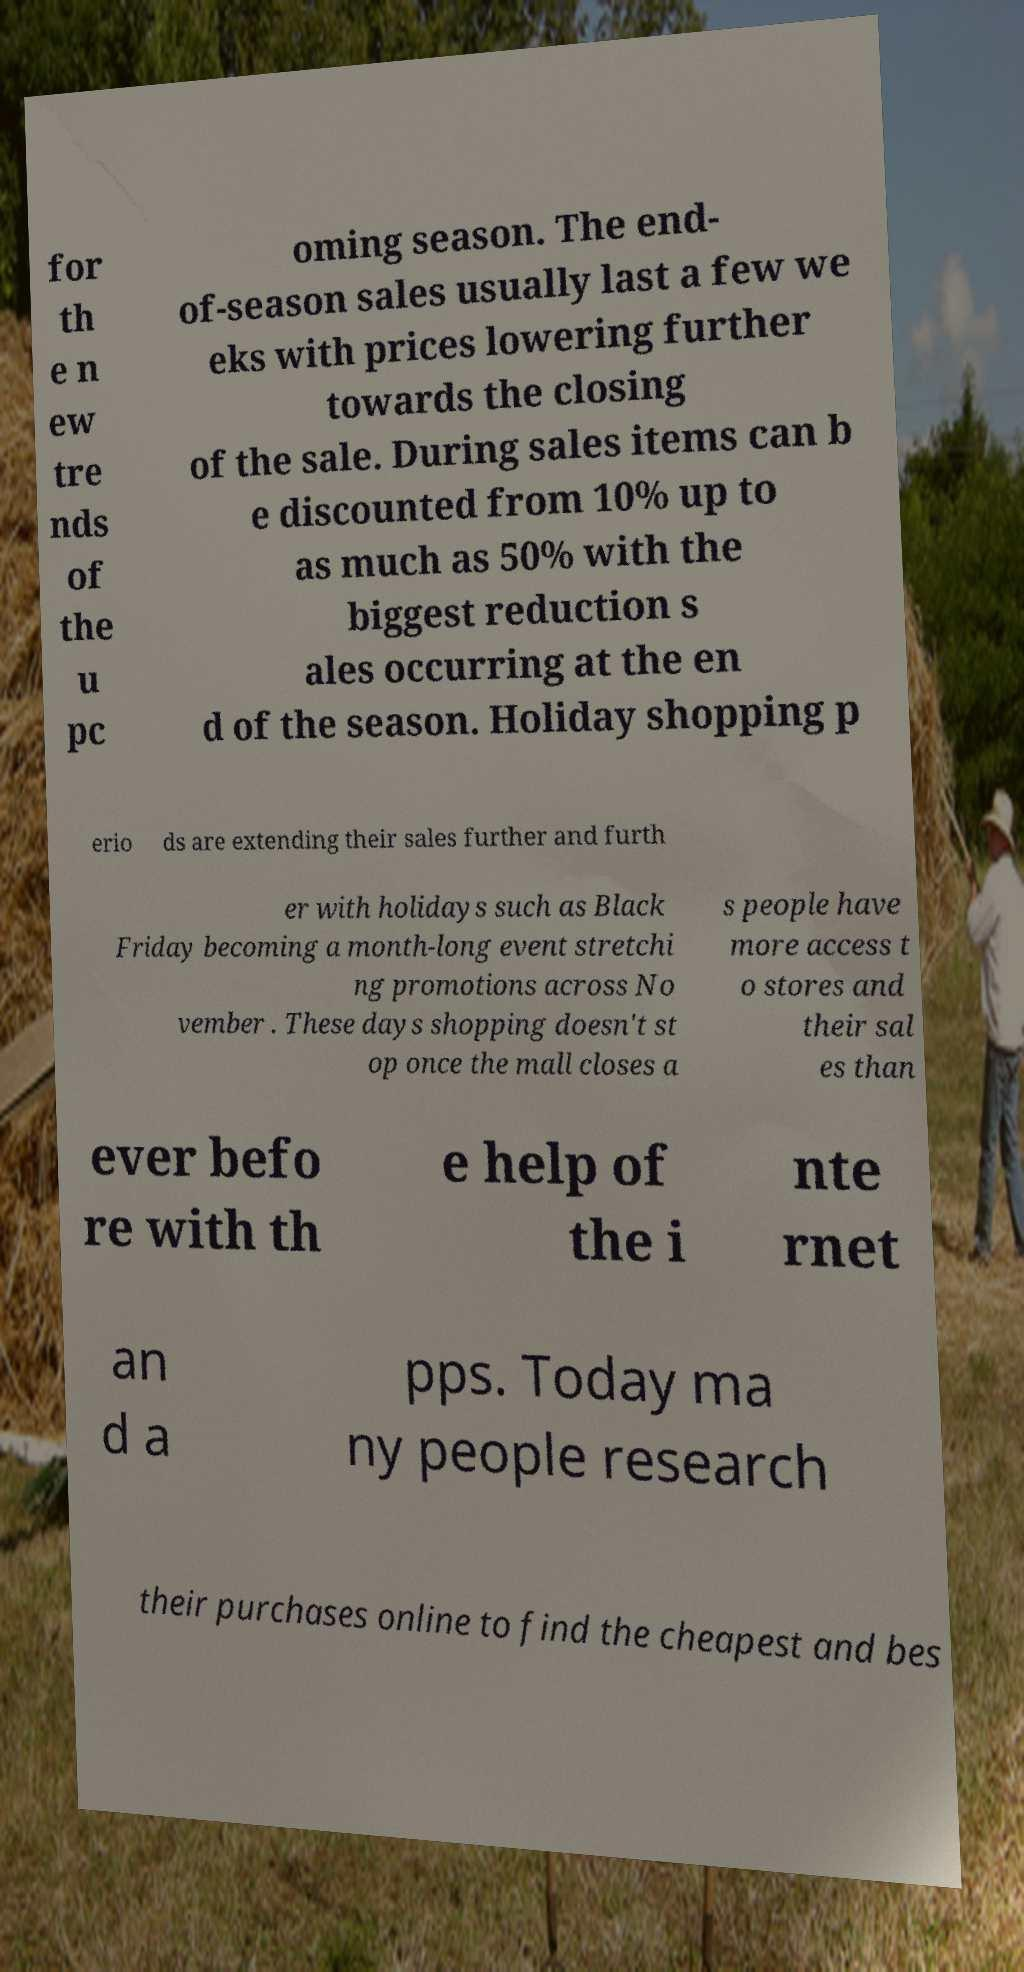For documentation purposes, I need the text within this image transcribed. Could you provide that? for th e n ew tre nds of the u pc oming season. The end- of-season sales usually last a few we eks with prices lowering further towards the closing of the sale. During sales items can b e discounted from 10% up to as much as 50% with the biggest reduction s ales occurring at the en d of the season. Holiday shopping p erio ds are extending their sales further and furth er with holidays such as Black Friday becoming a month-long event stretchi ng promotions across No vember . These days shopping doesn't st op once the mall closes a s people have more access t o stores and their sal es than ever befo re with th e help of the i nte rnet an d a pps. Today ma ny people research their purchases online to find the cheapest and bes 